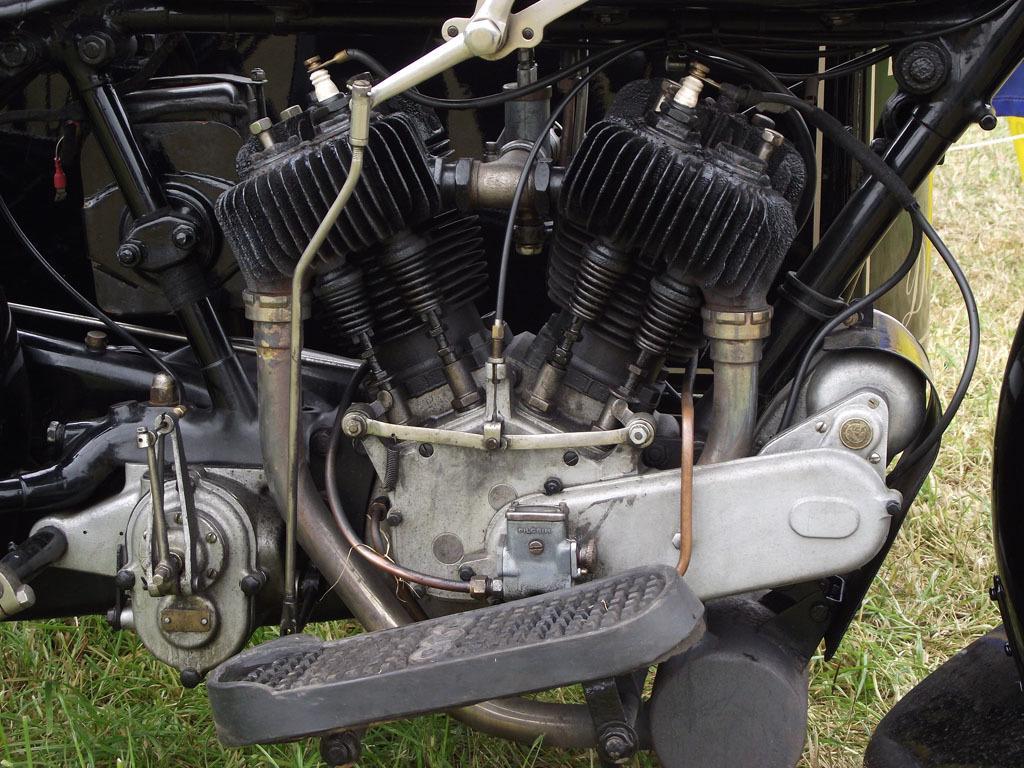How would you summarize this image in a sentence or two? In this image we can see an engine and grass. 